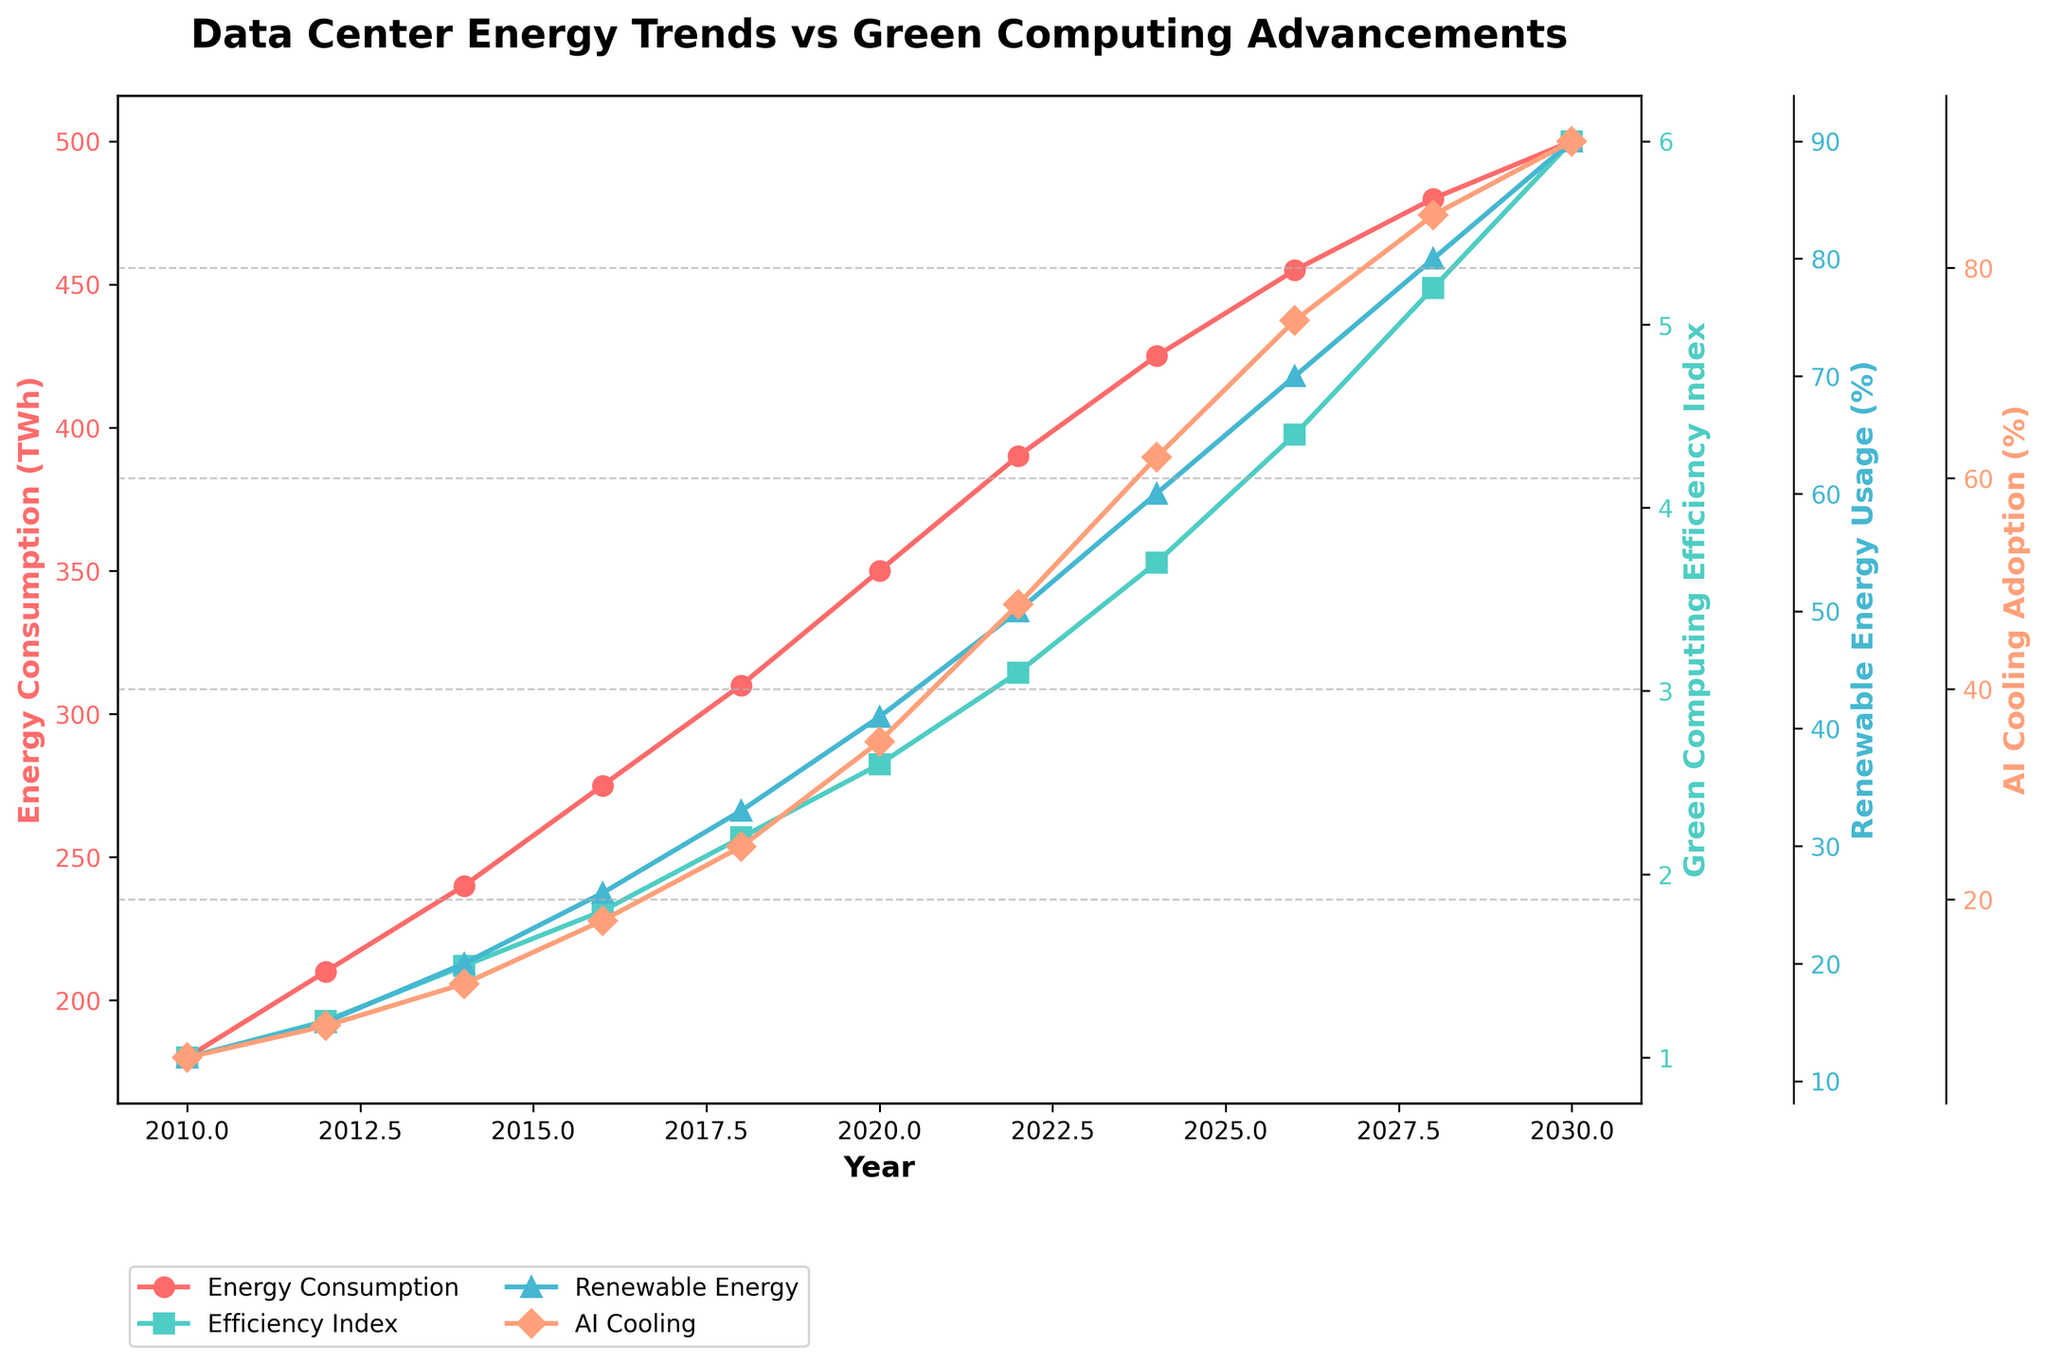What was the Data Center Energy Consumption (TWh) in 2028? To answer this question, look at the point corresponding to the year 2028 on the Energy Consumption trend line (red). The y-axis value for this point is 480 TWh.
Answer: 480 TWh By how much did the Green Computing Efficiency Index increase between 2014 and 2020? Identify the Efficiency Index values for 2014 and 2020 from the green line. In 2014, it is 1.5 and in 2020, it is 2.6. Subtract the 2014 value from the 2020 value (2.6 - 1.5).
Answer: 1.1 In which year was the Renewable Energy Usage (%) equal to 60%? Look at the Renewable Energy Usage line (blue) and find the year where it intersects the 60% marker on the y-axis. This occurs in 2024.
Answer: 2024 Compare the Data Center Energy Consumption in 2010 and 2020. Which year had higher consumption and by how much? For 2010, the energy consumption is 180 TWh. For 2020, it is 350 TWh. Subtract the 2010 value from the 2020 value (350 - 180). The 2020 value is higher.
Answer: 2020 by 170 TWh What trend is observed in AI-Optimized Cooling Systems Adoption (%) from 2010 to 2030? Observe the AI Cooling Adoption line (orange). It starts at 5% in 2010 and steadily increases to 92% by 2030. This shows a consistent upward trend.
Answer: Consistent upward trend What is the average Renewable Energy Usage (%) from 2010 to 2020? Sum the Renewable Energy Usage values from 2010 to 2020 (12 + 15 + 20 + 26 + 33 + 41) = 147%. There are 6 data points, so divide the sum by 6 to find the average (147 / 6).
Answer: 24.5% Which parameter shows the fastest growth rate from 2010 to 2030? Compare the slopes of the four lines. The Green Computing Efficiency Index line (green) shows the steepest incline, indicating the fastest rate of growth.
Answer: Green Computing Efficiency Index In which years did the Green Computing Efficiency Index surpass the Data Center Energy Consumption (divided by 100)? Compare the values of the Efficiency Index to the Energy Consumption divided by 100 (e.g., 180/100 = 1.8 for 2010). Look for intersections. This occurs from 2024 onwards.
Answer: From 2024 onward How much has the AI-Optimized Cooling Systems Adoption increased between 2014 and 2030? Find the AI Cooling Adoption values for 2014 (12%) and 2030 (92%). Subtract the 2014 value from the 2030 value (92 - 12).
Answer: 80% What was the overall trend in Data Center Energy Consumption from 2010 to 2030? Observe the red line. Data Center Energy Consumption starts at 180 TWh in 2010 and increases to 500 TWh by 2030. This indicates a consistent upward trend.
Answer: Consistent upward trend 